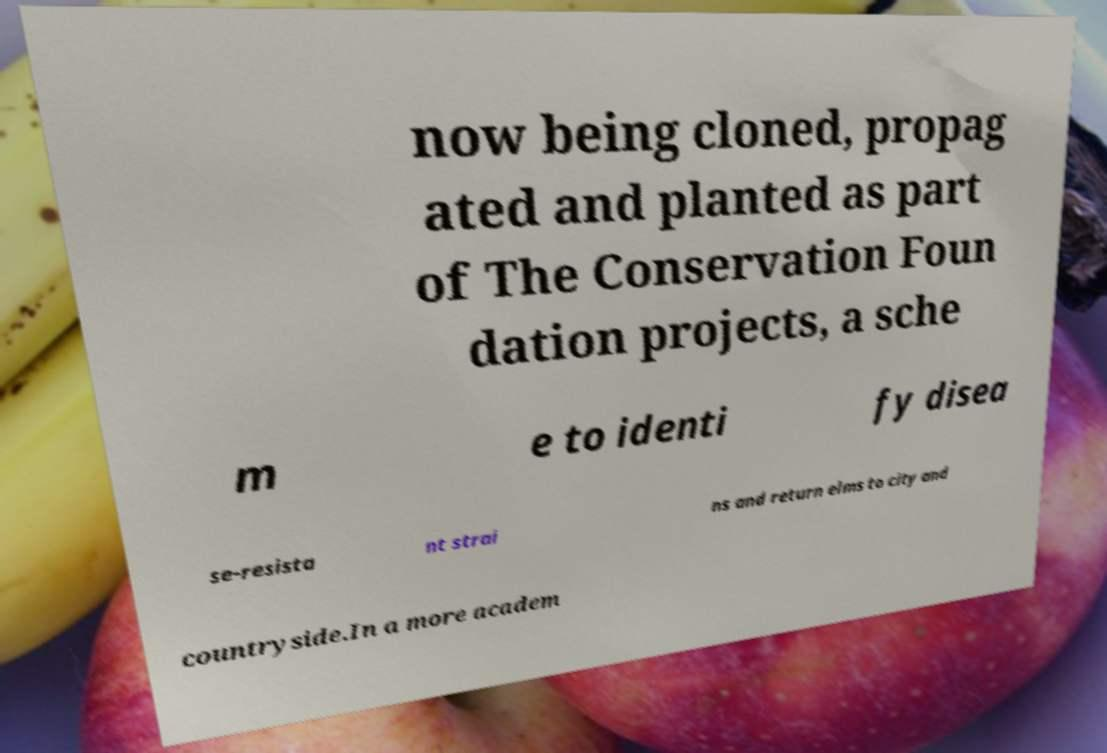Can you accurately transcribe the text from the provided image for me? now being cloned, propag ated and planted as part of The Conservation Foun dation projects, a sche m e to identi fy disea se-resista nt strai ns and return elms to city and countryside.In a more academ 